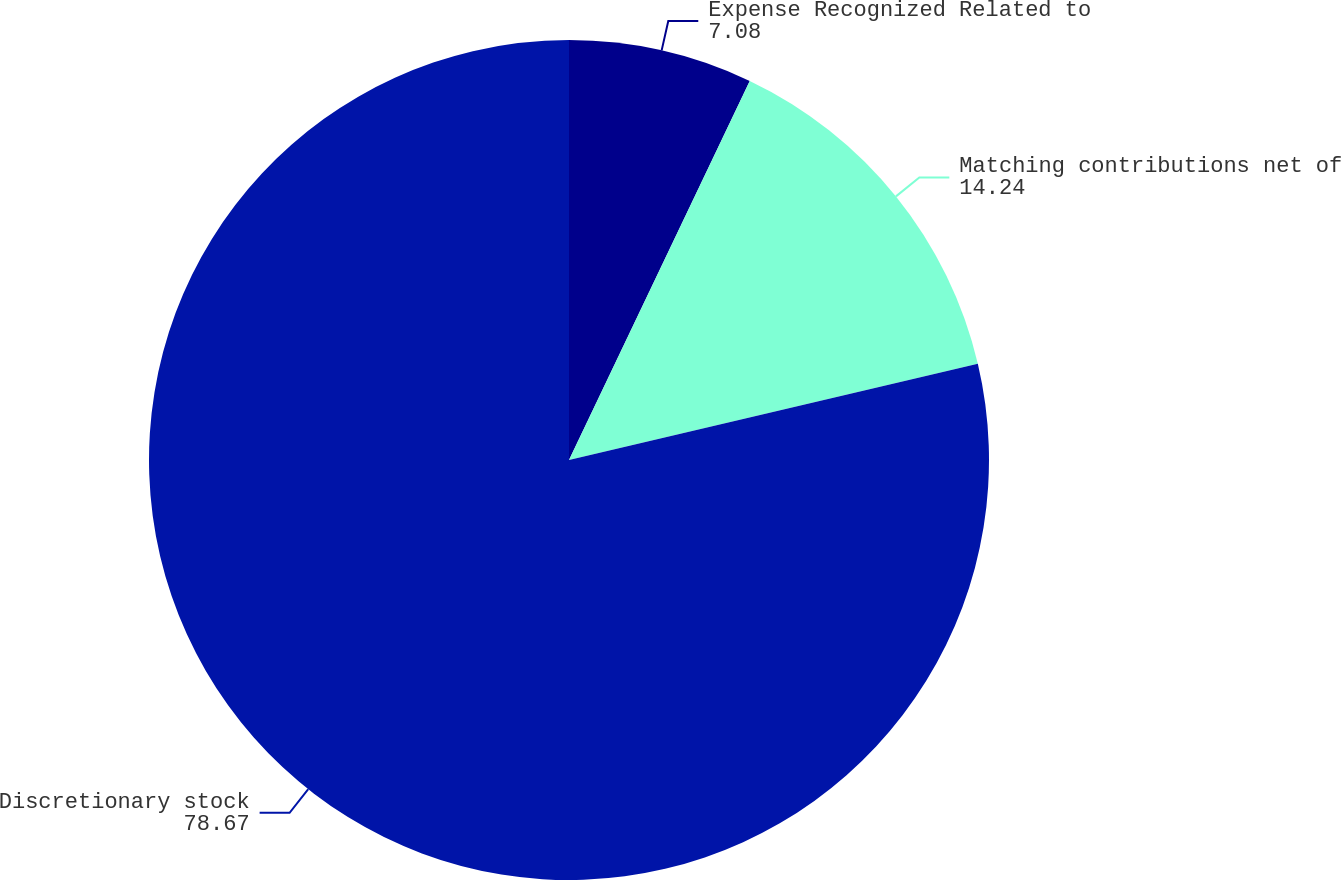Convert chart. <chart><loc_0><loc_0><loc_500><loc_500><pie_chart><fcel>Expense Recognized Related to<fcel>Matching contributions net of<fcel>Discretionary stock<nl><fcel>7.08%<fcel>14.24%<fcel>78.67%<nl></chart> 